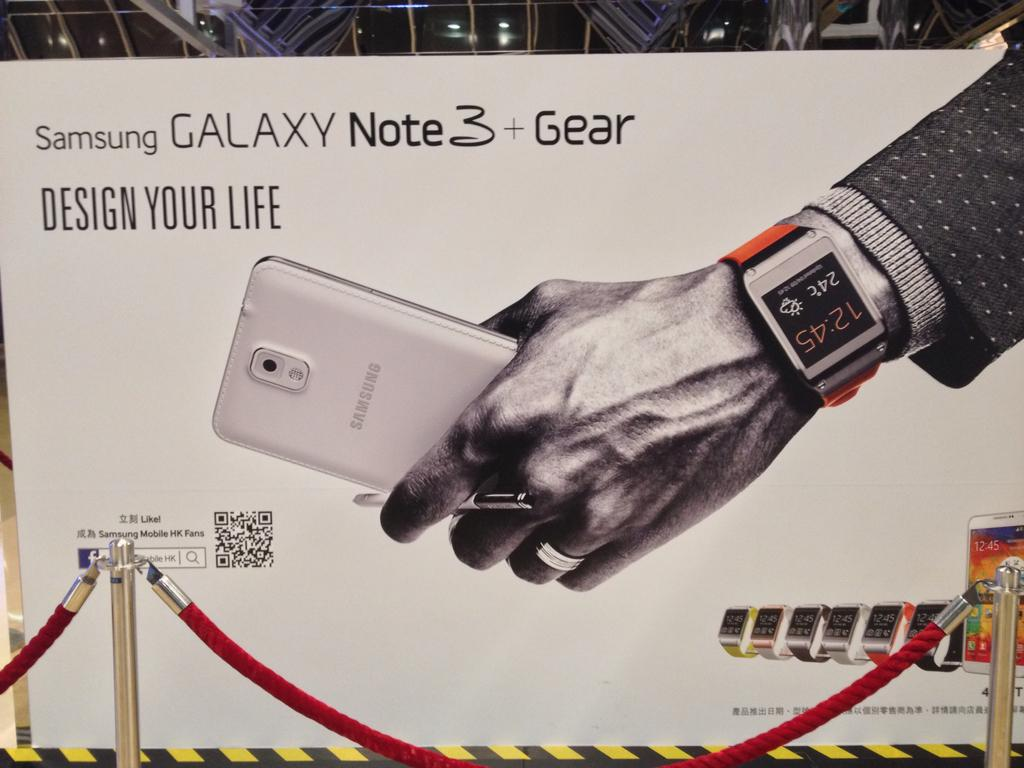<image>
Relay a brief, clear account of the picture shown. Advertisement showing a man holding a Samsung phone. 